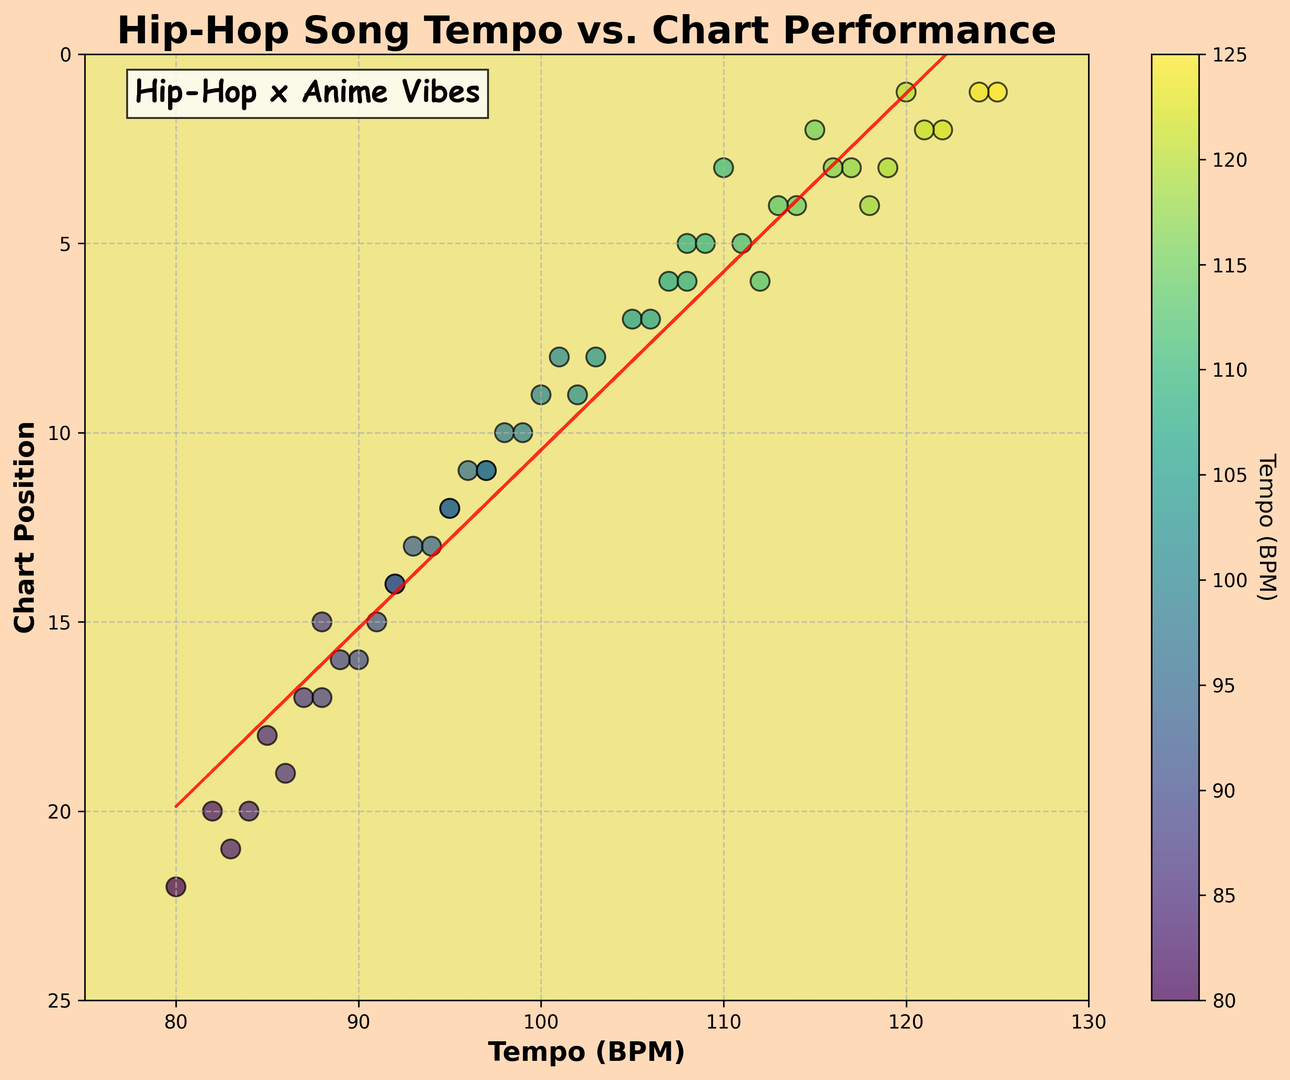What tempo has the highest chart position? The highest chart position is 1. By looking at the inverted y-axis, the data points at the top of the chart position axis represent the highest positions. The tempos with chart position 1 are 120 BPM, 125 BPM, and 124 BPM.
Answer: 120 BPM, 125 BPM, and 124 BPM What is the range of tempos shown in the plot? The x-axis ranges from 75 BPM to 130 BPM, indicating the tempo range on the scatter plot.
Answer: 75 BPM to 130 BPM Is there a general trend between tempo and chart position? From the visual observation of the red dashed trend line, it appears to have a negative slope, suggesting that higher tempos generally correlate with better (lower) chart positions.
Answer: Higher tempo, better chart position Which tempo is associated with a chart position of 10? By locating the points along the y-axis at position 10 and checking their corresponding x-axis values, the tempos are 98 BPM, 100 BPM, 97 BPM, and 99 BPM.
Answer: 98 BPM, 100 BPM, 97 BPM, and 99 BPM What is the tempo range for the top 5 chart positions? By scanning the top 5 positions on the y-axis and noting the tempos of the corresponding points, the range is from approximately 108 BPM to 125 BPM.
Answer: 108 BPM to 125 BPM What is the average tempo for songs in the top 5 chart positions? Identify the tempos at chart positions 1, 2, 3, 4, and 5 (which are 120 BPM, 125 BPM, 124 BPM, 115 BPM, 118 BPM, 108 BPM, 111 BPM, 109 BPM). The average is calculated as (120 + 125 + 124 + 115 + 118 + 108 + 111 + 109) / 8 = 115 BPM.
Answer: 115 BPM How many songs have a tempo between 90 BPM and 100 BPM? Count the data points on the x-axis between 90 BPM and 100 BPM. There are 10 such points (92, 94, 96, 97, 98, 99, 93, 95, 97, and 100 BPM).
Answer: 10 Which color on the scatter plot represents the highest tempo? Observe the color bar on the right of the plot. The highest tempo (125 BPM) is represented in a dark green color.
Answer: Dark green Are there any outliers in the chart position at lower tempos? Focus on the left side of the x-axis, particularly below 90 BPM, and observe if some points deviate significantly from the pattern. The point at 80 BPM and chart position 22 appears to be an outlier.
Answer: Yes, at 80 BPM What is the chart position for a song with a tempo of 82 BPM? Locate the point corresponding to 82 BPM on the x-axis and trace it to the y-axis. The chart position is 20.
Answer: 20 